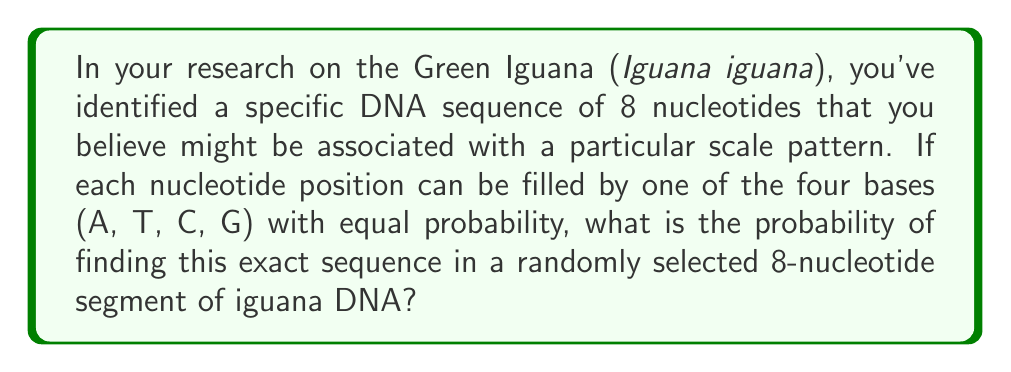Teach me how to tackle this problem. To solve this problem, we need to follow these steps:

1. Understand the given information:
   - We are looking for a specific sequence of 8 nucleotides
   - Each position can be filled by one of four bases (A, T, C, G)
   - The bases occur with equal probability

2. Calculate the probability of getting the correct nucleotide in one position:
   - For each position, the probability is $\frac{1}{4}$ (1 out of 4 choices)

3. Calculate the probability of getting the correct nucleotide in all 8 positions:
   - Since we need all 8 positions to be correct, and the events are independent, we multiply the probabilities:
   $$P(\text{correct sequence}) = \left(\frac{1}{4}\right)^8$$

4. Simplify the expression:
   $$P(\text{correct sequence}) = \frac{1}{4^8} = \frac{1}{65536}$$

Therefore, the probability of finding this exact 8-nucleotide sequence in a randomly selected segment of iguana DNA is $\frac{1}{65536}$ or approximately 0.0000152587890625.
Answer: $\frac{1}{65536}$ 